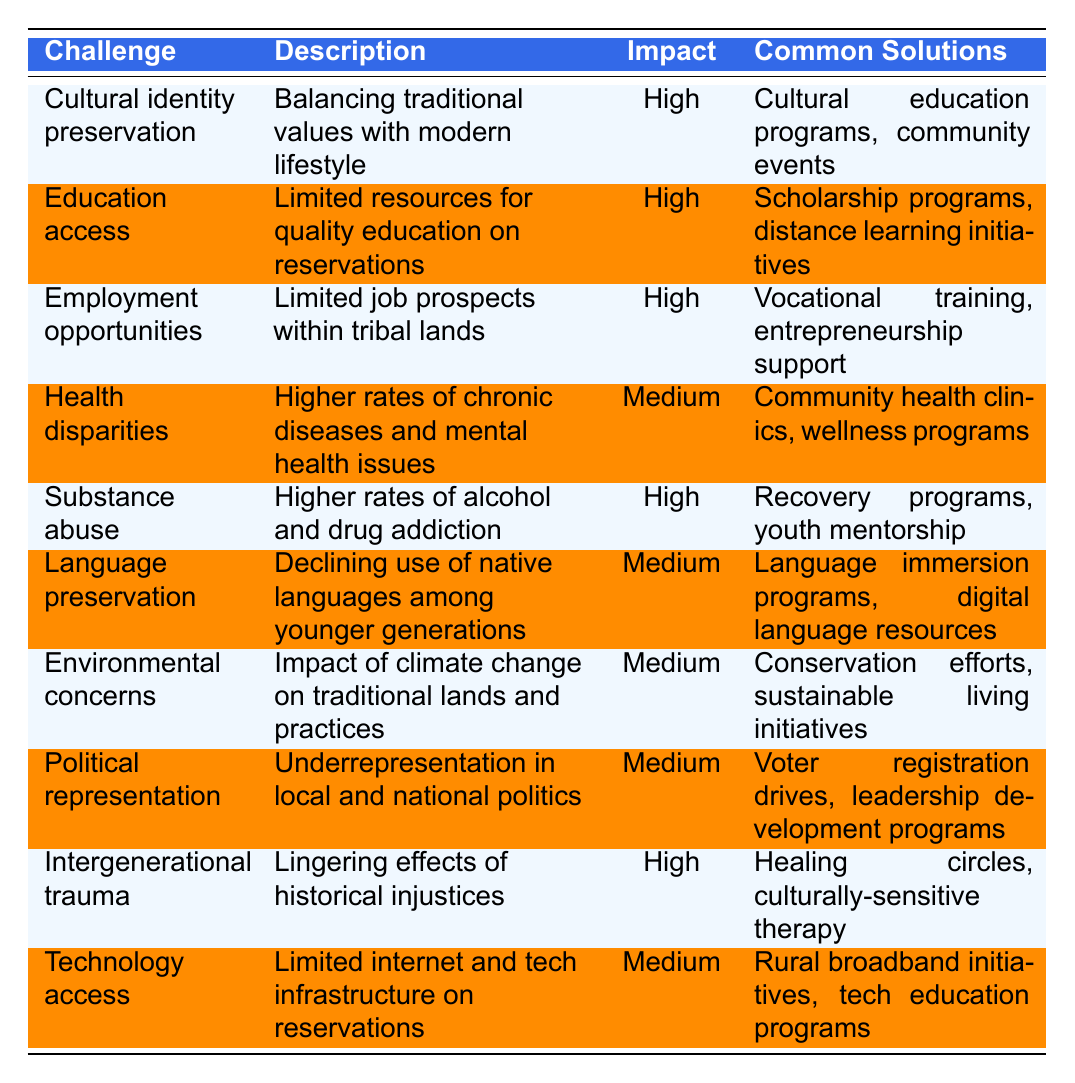What are the common solutions for the challenge of "Substance abuse"? Looking at the table under "Substance abuse," the common solutions listed are "Recovery programs, youth mentorship."
Answer: Recovery programs, youth mentorship Which challenge has the highest impact level? Reviewing the "Impact Level" column, the challenges with a "High" impact level are "Cultural identity preservation," "Education access," "Employment opportunities," "Substance abuse," and "Intergenerational trauma."
Answer: Cultural identity preservation, Education access, Employment opportunities, Substance abuse, Intergenerational trauma What is the impact level of "Health disparities"? The impact level for "Health disparities" is listed as "Medium" in the table.
Answer: Medium How many challenges are listed in the table? Counting the rows in the table, there are 10 distinct challenges listed.
Answer: 10 Are there any challenges that focus on language? By examining the table, there is a challenge called "Language preservation," which directly pertains to language issues.
Answer: Yes What are the common solutions for challenges with a "Medium" impact level? The challenges with a "Medium" impact level include "Health disparities," "Language preservation," "Environmental concerns," "Political representation," and "Technology access." Their common solutions are "Community health clinics, wellness programs," "Language immersion programs, digital language resources," "Conservation efforts, sustainable living initiatives," "Voter registration drives, leadership development programs," and "Rural broadband initiatives, tech education programs."
Answer: Community health clinics, wellness programs; Language immersion programs, digital language resources; Conservation efforts, sustainable living initiatives; Voter registration drives, leadership development programs; Rural broadband initiatives, tech education programs Which challenge has solutions aimed at education? From the table, "Education access" and "Language preservation" both have common solutions that focus on educational aspects.
Answer: Education access, Language preservation What proportion of the challenges listed have a "High" impact level? There are 5 challenges with a "High" impact level and a total of 10 challenges in the table. Therefore, the proportion is 5 out of 10, or 50%.
Answer: 50% Is "Environmental concerns" listed as a high impact challenge? A look at the impact level for "Environmental concerns" indicates it is categorized as "Medium," not "High."
Answer: No Which common solution appears for both high impact and medium impact challenges? By analyzing the solutions, vocational training appears as a common solution for "Employment opportunities" (high impact) and distance learning initiatives for "Education access" (also high impact), which is distinct from any medium impact challenge solution. Hence, none is shared between high and medium.
Answer: None 